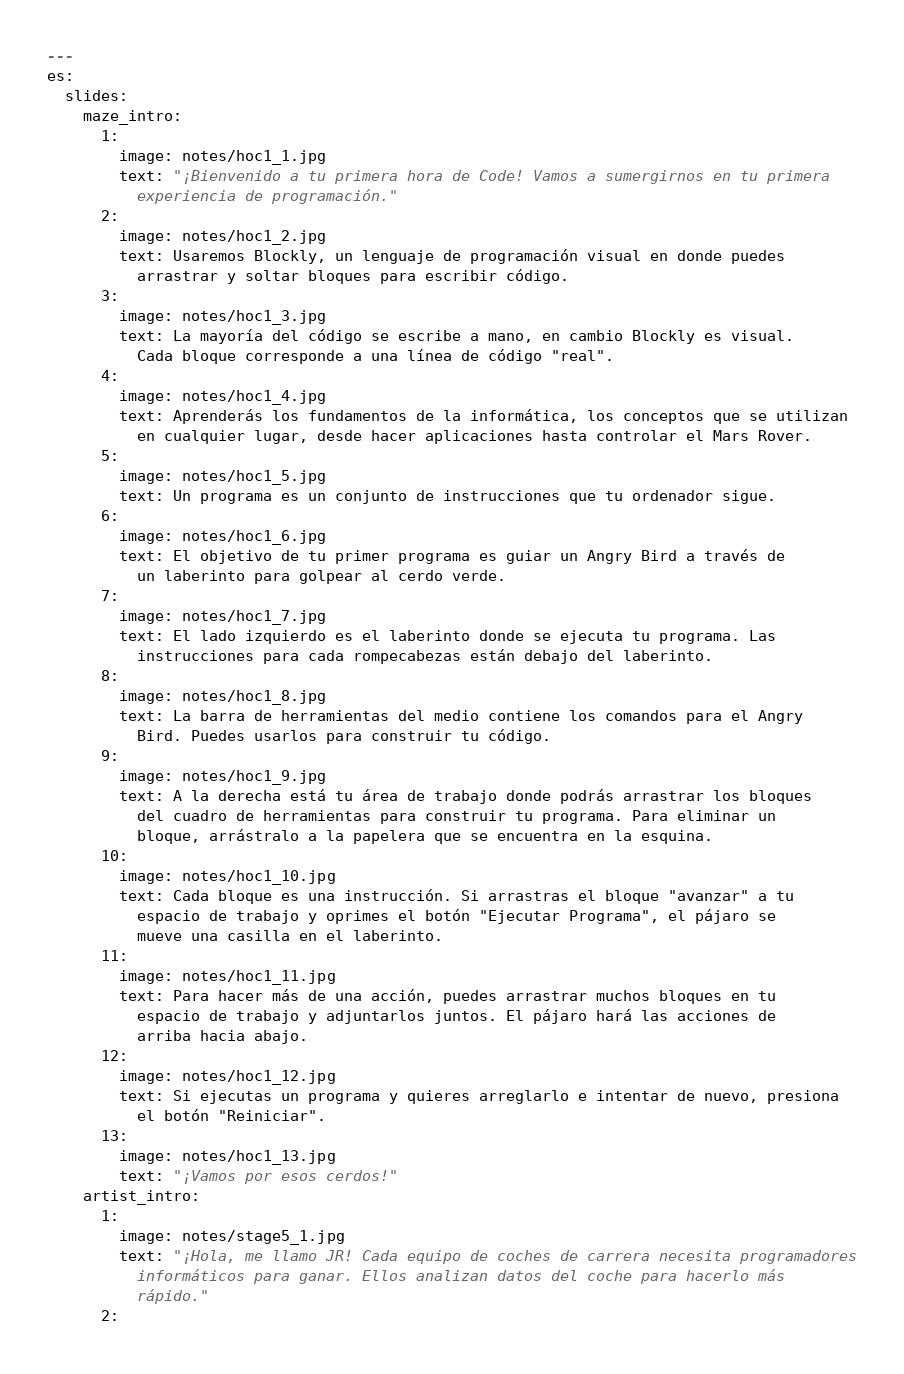Convert code to text. <code><loc_0><loc_0><loc_500><loc_500><_YAML_>---
es:
  slides:
    maze_intro:
      1:
        image: notes/hoc1_1.jpg
        text: "¡Bienvenido a tu primera hora de Code! Vamos a sumergirnos en tu primera
          experiencia de programación."
      2:
        image: notes/hoc1_2.jpg
        text: Usaremos Blockly, un lenguaje de programación visual en donde puedes
          arrastrar y soltar bloques para escribir código.
      3:
        image: notes/hoc1_3.jpg
        text: La mayoría del código se escribe a mano, en cambio Blockly es visual.
          Cada bloque corresponde a una línea de código "real".
      4:
        image: notes/hoc1_4.jpg
        text: Aprenderás los fundamentos de la informática, los conceptos que se utilizan
          en cualquier lugar, desde hacer aplicaciones hasta controlar el Mars Rover.
      5:
        image: notes/hoc1_5.jpg
        text: Un programa es un conjunto de instrucciones que tu ordenador sigue.
      6:
        image: notes/hoc1_6.jpg
        text: El objetivo de tu primer programa es guiar un Angry Bird a través de
          un laberinto para golpear al cerdo verde.
      7:
        image: notes/hoc1_7.jpg
        text: El lado izquierdo es el laberinto donde se ejecuta tu programa. Las
          instrucciones para cada rompecabezas están debajo del laberinto.
      8:
        image: notes/hoc1_8.jpg
        text: La barra de herramientas del medio contiene los comandos para el Angry
          Bird. Puedes usarlos para construir tu código.
      9:
        image: notes/hoc1_9.jpg
        text: A la derecha está tu área de trabajo donde podrás arrastrar los bloques
          del cuadro de herramientas para construir tu programa. Para eliminar un
          bloque, arrástralo a la papelera que se encuentra en la esquina.
      10:
        image: notes/hoc1_10.jpg
        text: Cada bloque es una instrucción. Si arrastras el bloque "avanzar" a tu
          espacio de trabajo y oprimes el botón "Ejecutar Programa", el pájaro se
          mueve una casilla en el laberinto.
      11:
        image: notes/hoc1_11.jpg
        text: Para hacer más de una acción, puedes arrastrar muchos bloques en tu
          espacio de trabajo y adjuntarlos juntos. El pájaro hará las acciones de
          arriba hacia abajo.
      12:
        image: notes/hoc1_12.jpg
        text: Si ejecutas un programa y quieres arreglarlo e intentar de nuevo, presiona
          el botón "Reiniciar".
      13:
        image: notes/hoc1_13.jpg
        text: "¡Vamos por esos cerdos!"
    artist_intro:
      1:
        image: notes/stage5_1.jpg
        text: "¡Hola, me llamo JR! Cada equipo de coches de carrera necesita programadores
          informáticos para ganar. Ellos analizan datos del coche para hacerlo más
          rápido."
      2:</code> 